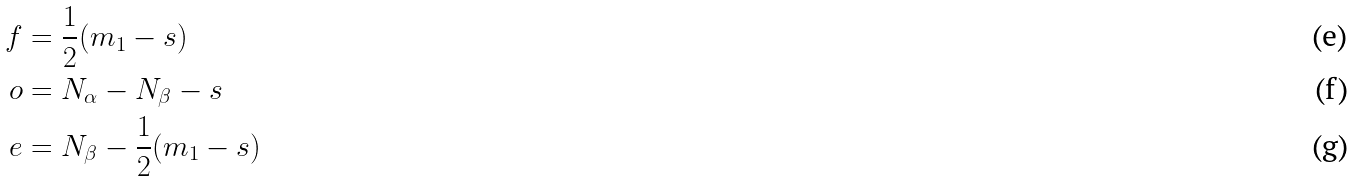<formula> <loc_0><loc_0><loc_500><loc_500>f & = \frac { 1 } { 2 } ( m _ { 1 } - s ) \\ o & = N _ { \alpha } - N _ { \beta } - s \\ e & = N _ { \beta } - \frac { 1 } { 2 } ( m _ { 1 } - s )</formula> 